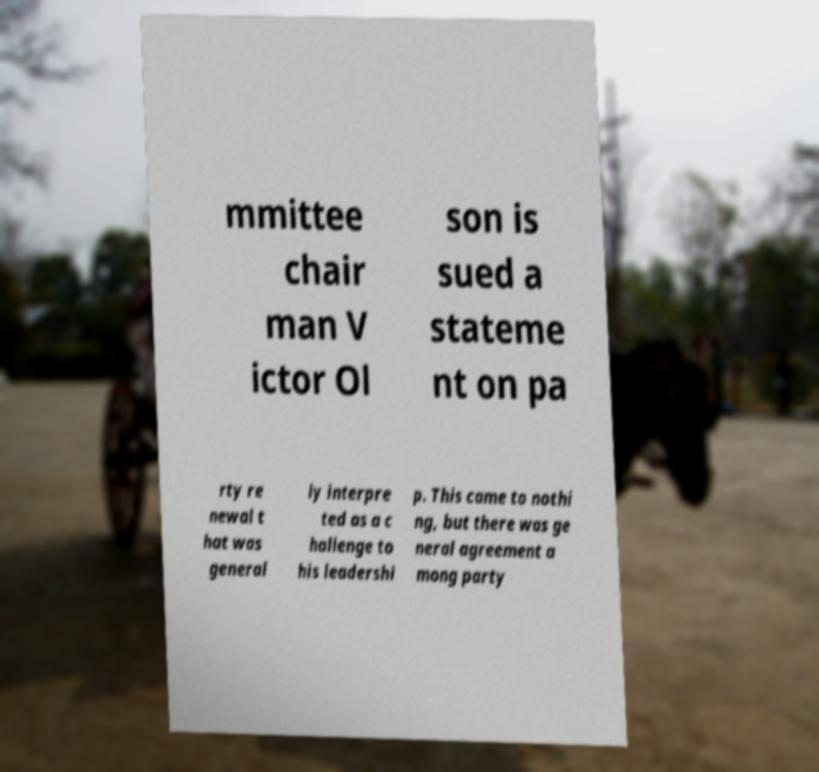I need the written content from this picture converted into text. Can you do that? mmittee chair man V ictor Ol son is sued a stateme nt on pa rty re newal t hat was general ly interpre ted as a c hallenge to his leadershi p. This came to nothi ng, but there was ge neral agreement a mong party 